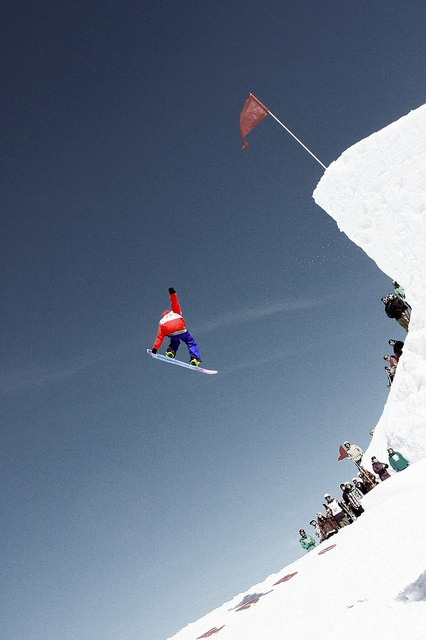Describe the objects in this image and their specific colors. I can see people in black, white, darkgray, and gray tones, people in black, red, gray, and navy tones, snowboard in black, lightblue, darkgray, lavender, and gray tones, people in black, gray, darkgray, and lightgray tones, and people in black, gray, lightgray, and darkgray tones in this image. 